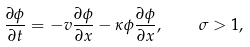Convert formula to latex. <formula><loc_0><loc_0><loc_500><loc_500>\frac { \partial \phi } { \partial t } = - v \frac { \partial \phi } { \partial x } - \kappa \phi \frac { \partial \phi } { \partial x } , \quad \sigma > 1 ,</formula> 